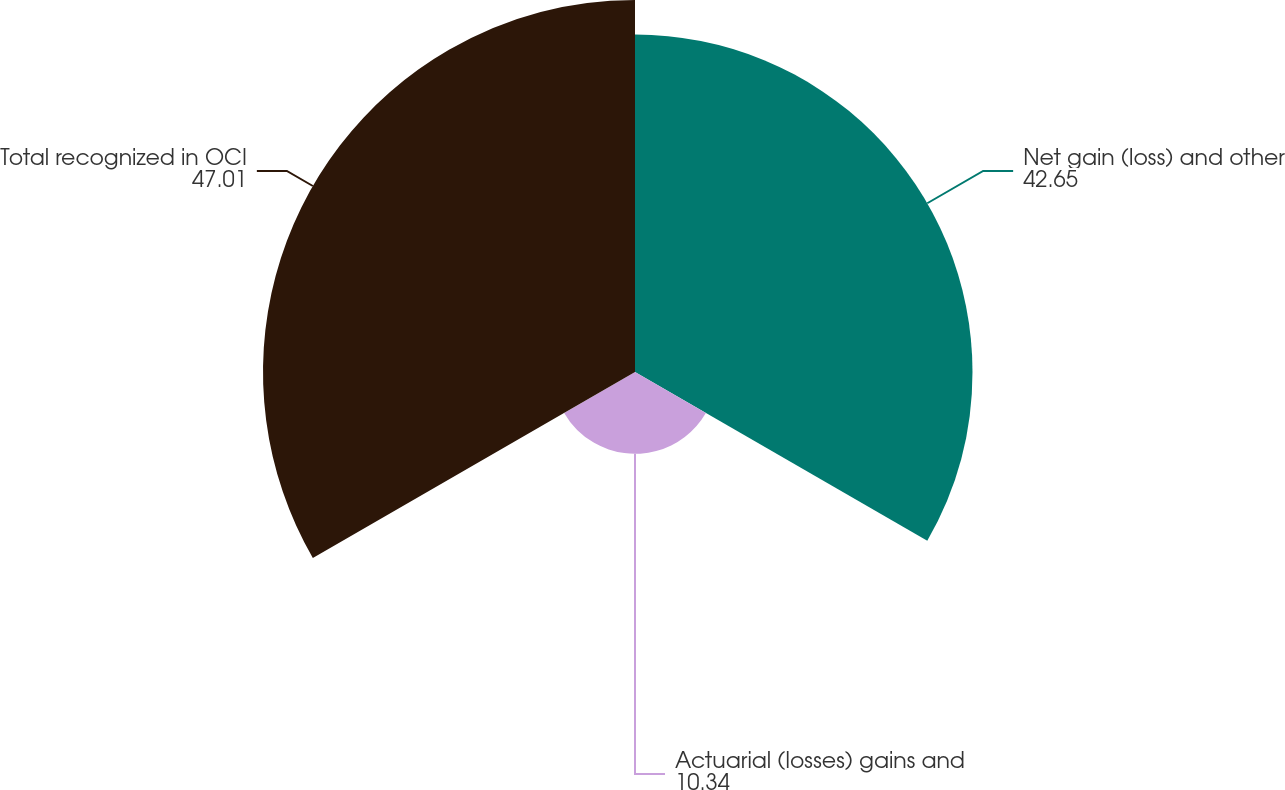<chart> <loc_0><loc_0><loc_500><loc_500><pie_chart><fcel>Net gain (loss) and other<fcel>Actuarial (losses) gains and<fcel>Total recognized in OCI<nl><fcel>42.65%<fcel>10.34%<fcel>47.01%<nl></chart> 